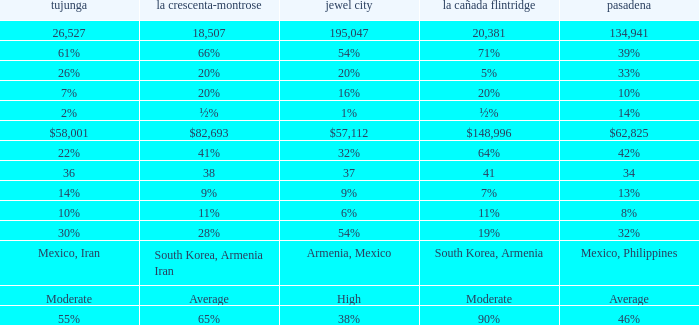What is the percentage of Glendale when La Canada Flintridge is 5%? 20%. 